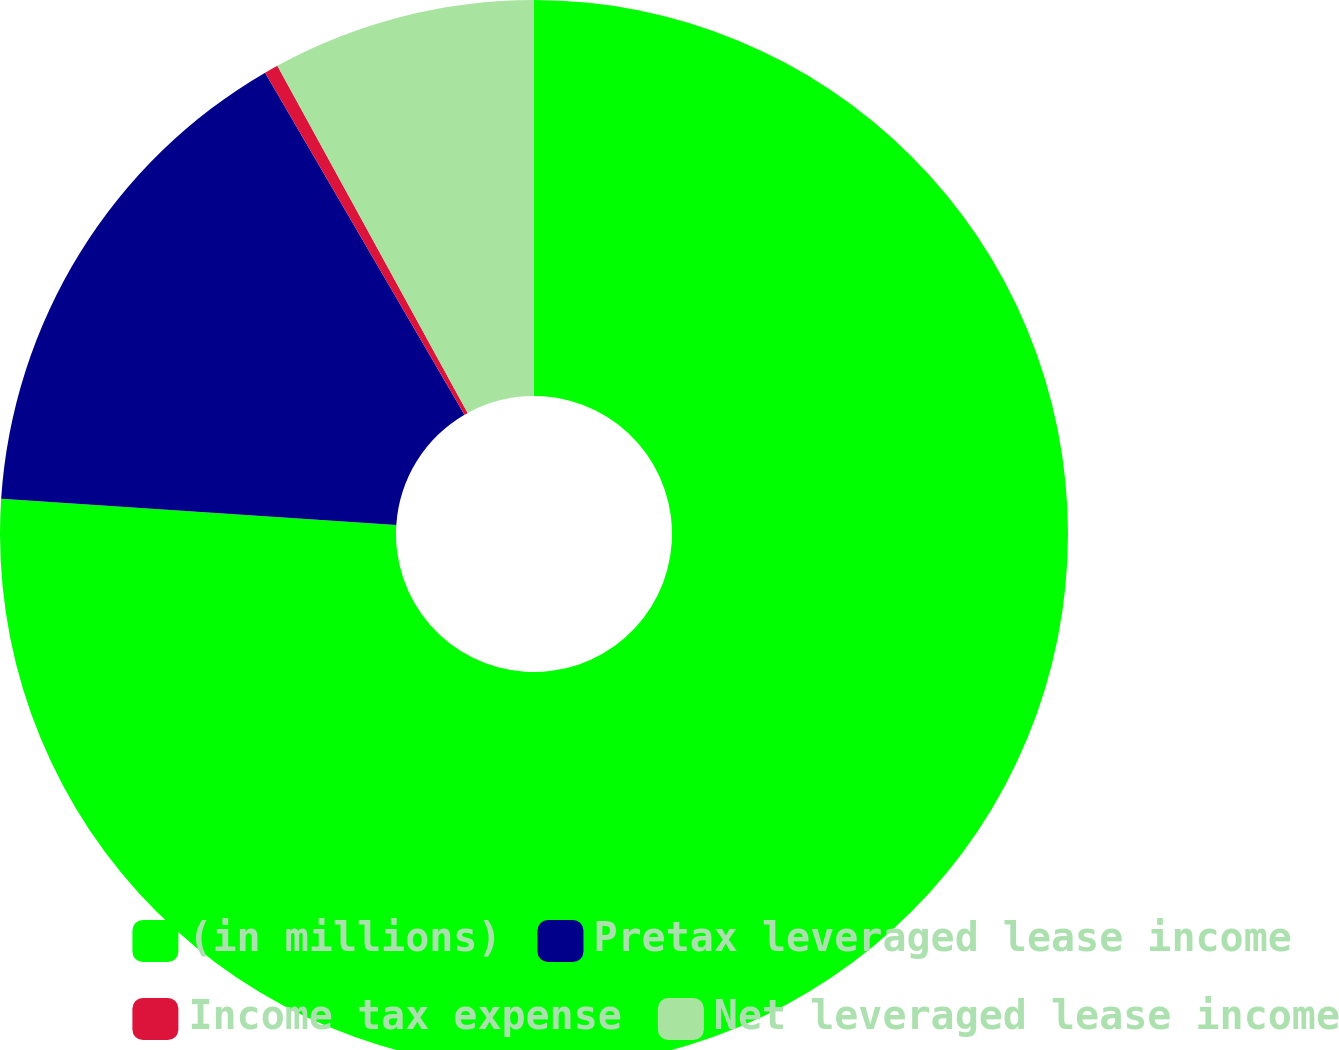Convert chart. <chart><loc_0><loc_0><loc_500><loc_500><pie_chart><fcel>(in millions)<fcel>Pretax leveraged lease income<fcel>Income tax expense<fcel>Net leveraged lease income<nl><fcel>76.06%<fcel>15.55%<fcel>0.42%<fcel>7.98%<nl></chart> 